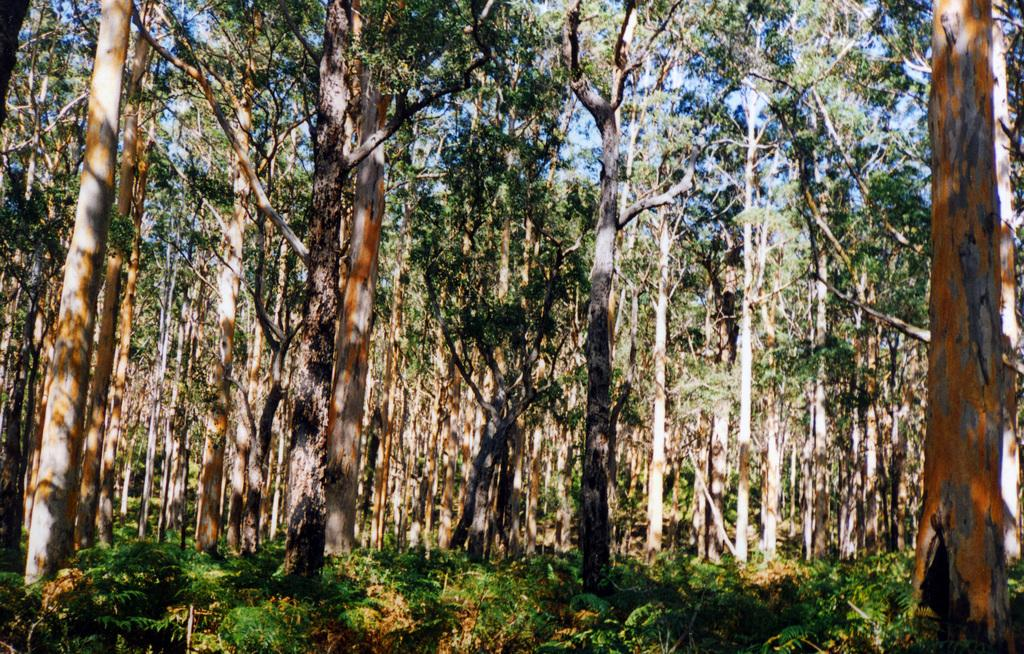What type of vegetation can be seen in the image? There are trees and plants on the ground in the image. What can be seen in the background of the image? The sky is visible in the background of the image. How many men are visible in the image? There are no men present in the image; it features trees, plants, and the sky. 